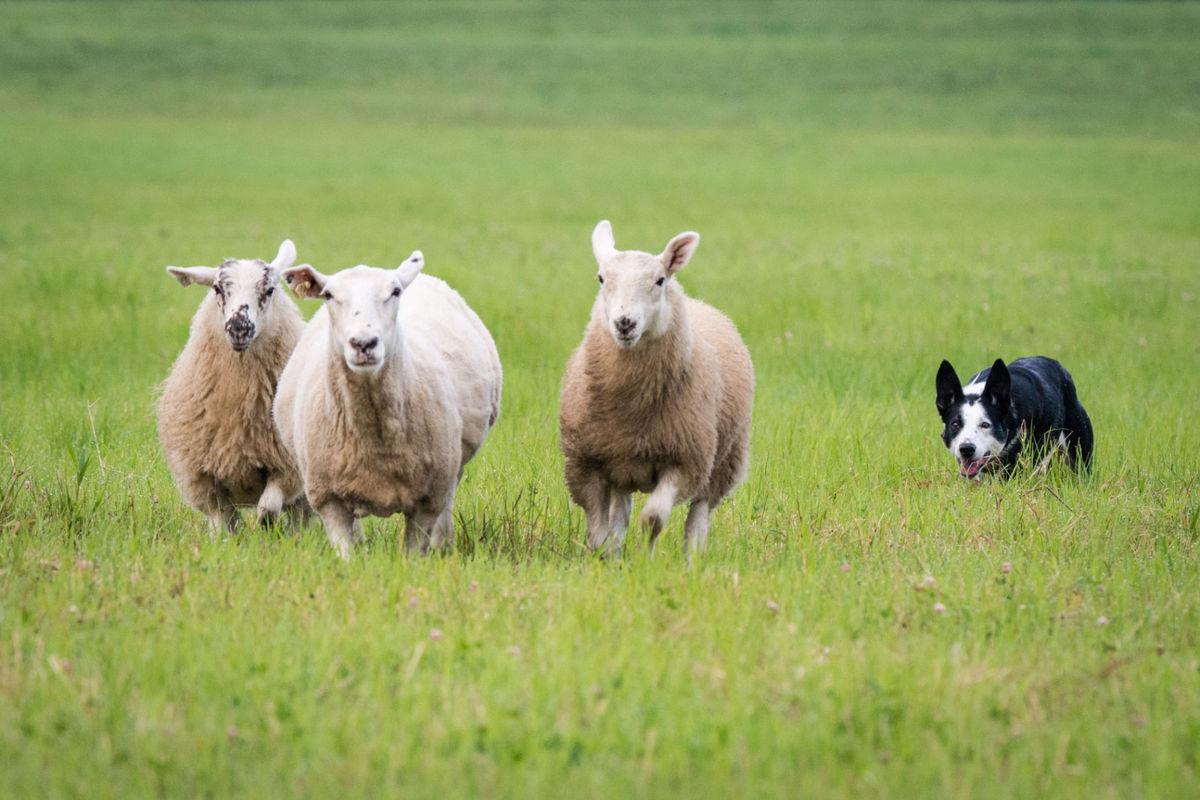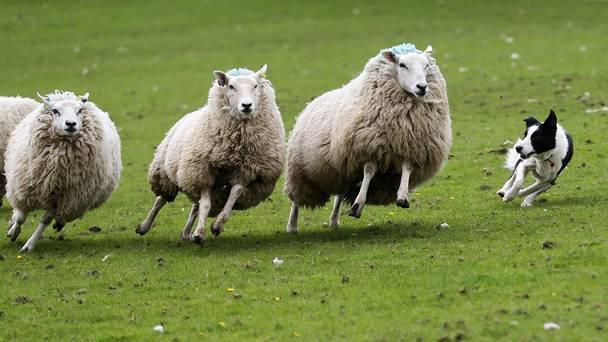The first image is the image on the left, the second image is the image on the right. Examine the images to the left and right. Is the description "At least one image shows a dog at the right herding no more than three sheep, which are at the left." accurate? Answer yes or no. Yes. 